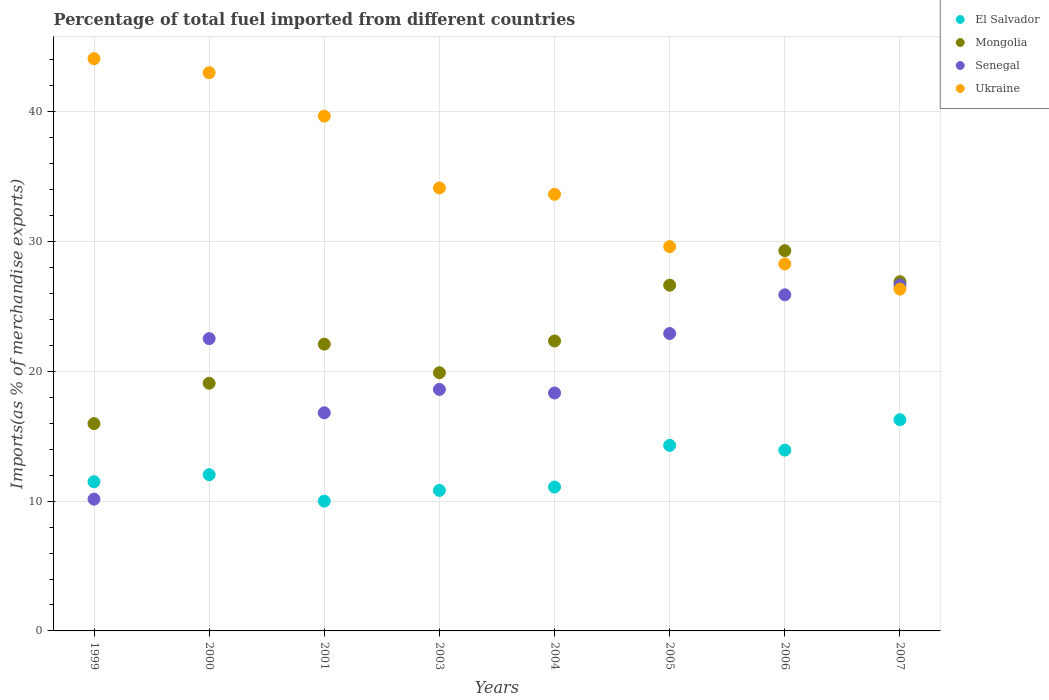Is the number of dotlines equal to the number of legend labels?
Keep it short and to the point. Yes. What is the percentage of imports to different countries in Ukraine in 2003?
Keep it short and to the point. 34.13. Across all years, what is the maximum percentage of imports to different countries in El Salvador?
Your answer should be compact. 16.27. Across all years, what is the minimum percentage of imports to different countries in Senegal?
Make the answer very short. 10.15. In which year was the percentage of imports to different countries in Mongolia maximum?
Your answer should be very brief. 2006. What is the total percentage of imports to different countries in Mongolia in the graph?
Make the answer very short. 182.22. What is the difference between the percentage of imports to different countries in Mongolia in 2000 and that in 2004?
Your answer should be compact. -3.26. What is the difference between the percentage of imports to different countries in El Salvador in 2003 and the percentage of imports to different countries in Senegal in 2005?
Make the answer very short. -12.09. What is the average percentage of imports to different countries in Mongolia per year?
Your response must be concise. 22.78. In the year 2000, what is the difference between the percentage of imports to different countries in El Salvador and percentage of imports to different countries in Mongolia?
Provide a succinct answer. -7.04. In how many years, is the percentage of imports to different countries in Ukraine greater than 18 %?
Offer a terse response. 8. What is the ratio of the percentage of imports to different countries in Ukraine in 1999 to that in 2004?
Give a very brief answer. 1.31. What is the difference between the highest and the second highest percentage of imports to different countries in Senegal?
Give a very brief answer. 0.76. What is the difference between the highest and the lowest percentage of imports to different countries in El Salvador?
Your answer should be compact. 6.27. Is the sum of the percentage of imports to different countries in Ukraine in 2000 and 2005 greater than the maximum percentage of imports to different countries in Mongolia across all years?
Provide a short and direct response. Yes. Is it the case that in every year, the sum of the percentage of imports to different countries in Ukraine and percentage of imports to different countries in Mongolia  is greater than the sum of percentage of imports to different countries in El Salvador and percentage of imports to different countries in Senegal?
Your answer should be compact. Yes. Is it the case that in every year, the sum of the percentage of imports to different countries in Mongolia and percentage of imports to different countries in Ukraine  is greater than the percentage of imports to different countries in Senegal?
Give a very brief answer. Yes. How many dotlines are there?
Offer a very short reply. 4. How many years are there in the graph?
Offer a terse response. 8. Are the values on the major ticks of Y-axis written in scientific E-notation?
Your answer should be compact. No. Does the graph contain any zero values?
Provide a short and direct response. No. Does the graph contain grids?
Offer a very short reply. Yes. Where does the legend appear in the graph?
Keep it short and to the point. Top right. How are the legend labels stacked?
Your response must be concise. Vertical. What is the title of the graph?
Give a very brief answer. Percentage of total fuel imported from different countries. Does "Swaziland" appear as one of the legend labels in the graph?
Give a very brief answer. No. What is the label or title of the Y-axis?
Give a very brief answer. Imports(as % of merchandise exports). What is the Imports(as % of merchandise exports) of El Salvador in 1999?
Provide a succinct answer. 11.49. What is the Imports(as % of merchandise exports) of Mongolia in 1999?
Provide a short and direct response. 15.97. What is the Imports(as % of merchandise exports) in Senegal in 1999?
Ensure brevity in your answer.  10.15. What is the Imports(as % of merchandise exports) of Ukraine in 1999?
Your answer should be very brief. 44.09. What is the Imports(as % of merchandise exports) of El Salvador in 2000?
Ensure brevity in your answer.  12.04. What is the Imports(as % of merchandise exports) in Mongolia in 2000?
Your response must be concise. 19.08. What is the Imports(as % of merchandise exports) in Senegal in 2000?
Make the answer very short. 22.52. What is the Imports(as % of merchandise exports) in Ukraine in 2000?
Offer a very short reply. 43.01. What is the Imports(as % of merchandise exports) in El Salvador in 2001?
Offer a very short reply. 10. What is the Imports(as % of merchandise exports) of Mongolia in 2001?
Provide a short and direct response. 22.09. What is the Imports(as % of merchandise exports) in Senegal in 2001?
Your answer should be compact. 16.8. What is the Imports(as % of merchandise exports) of Ukraine in 2001?
Offer a very short reply. 39.66. What is the Imports(as % of merchandise exports) of El Salvador in 2003?
Offer a very short reply. 10.83. What is the Imports(as % of merchandise exports) of Mongolia in 2003?
Your response must be concise. 19.89. What is the Imports(as % of merchandise exports) in Senegal in 2003?
Provide a succinct answer. 18.61. What is the Imports(as % of merchandise exports) of Ukraine in 2003?
Your answer should be compact. 34.13. What is the Imports(as % of merchandise exports) of El Salvador in 2004?
Your answer should be compact. 11.09. What is the Imports(as % of merchandise exports) of Mongolia in 2004?
Offer a terse response. 22.34. What is the Imports(as % of merchandise exports) in Senegal in 2004?
Keep it short and to the point. 18.33. What is the Imports(as % of merchandise exports) of Ukraine in 2004?
Your answer should be very brief. 33.64. What is the Imports(as % of merchandise exports) of El Salvador in 2005?
Keep it short and to the point. 14.29. What is the Imports(as % of merchandise exports) in Mongolia in 2005?
Give a very brief answer. 26.64. What is the Imports(as % of merchandise exports) in Senegal in 2005?
Provide a short and direct response. 22.91. What is the Imports(as % of merchandise exports) of Ukraine in 2005?
Your answer should be compact. 29.61. What is the Imports(as % of merchandise exports) in El Salvador in 2006?
Give a very brief answer. 13.93. What is the Imports(as % of merchandise exports) of Mongolia in 2006?
Offer a very short reply. 29.3. What is the Imports(as % of merchandise exports) of Senegal in 2006?
Offer a very short reply. 25.9. What is the Imports(as % of merchandise exports) in Ukraine in 2006?
Provide a succinct answer. 28.27. What is the Imports(as % of merchandise exports) in El Salvador in 2007?
Offer a very short reply. 16.27. What is the Imports(as % of merchandise exports) of Mongolia in 2007?
Provide a succinct answer. 26.9. What is the Imports(as % of merchandise exports) in Senegal in 2007?
Offer a very short reply. 26.66. What is the Imports(as % of merchandise exports) of Ukraine in 2007?
Keep it short and to the point. 26.33. Across all years, what is the maximum Imports(as % of merchandise exports) of El Salvador?
Your answer should be very brief. 16.27. Across all years, what is the maximum Imports(as % of merchandise exports) in Mongolia?
Provide a short and direct response. 29.3. Across all years, what is the maximum Imports(as % of merchandise exports) in Senegal?
Ensure brevity in your answer.  26.66. Across all years, what is the maximum Imports(as % of merchandise exports) of Ukraine?
Your answer should be compact. 44.09. Across all years, what is the minimum Imports(as % of merchandise exports) of El Salvador?
Give a very brief answer. 10. Across all years, what is the minimum Imports(as % of merchandise exports) of Mongolia?
Your answer should be very brief. 15.97. Across all years, what is the minimum Imports(as % of merchandise exports) of Senegal?
Your answer should be very brief. 10.15. Across all years, what is the minimum Imports(as % of merchandise exports) in Ukraine?
Provide a short and direct response. 26.33. What is the total Imports(as % of merchandise exports) of El Salvador in the graph?
Ensure brevity in your answer.  99.94. What is the total Imports(as % of merchandise exports) in Mongolia in the graph?
Offer a terse response. 182.22. What is the total Imports(as % of merchandise exports) in Senegal in the graph?
Your answer should be compact. 161.88. What is the total Imports(as % of merchandise exports) of Ukraine in the graph?
Ensure brevity in your answer.  278.74. What is the difference between the Imports(as % of merchandise exports) in El Salvador in 1999 and that in 2000?
Your answer should be compact. -0.55. What is the difference between the Imports(as % of merchandise exports) in Mongolia in 1999 and that in 2000?
Ensure brevity in your answer.  -3.11. What is the difference between the Imports(as % of merchandise exports) in Senegal in 1999 and that in 2000?
Provide a short and direct response. -12.37. What is the difference between the Imports(as % of merchandise exports) in Ukraine in 1999 and that in 2000?
Your response must be concise. 1.08. What is the difference between the Imports(as % of merchandise exports) in El Salvador in 1999 and that in 2001?
Offer a very short reply. 1.49. What is the difference between the Imports(as % of merchandise exports) in Mongolia in 1999 and that in 2001?
Give a very brief answer. -6.12. What is the difference between the Imports(as % of merchandise exports) of Senegal in 1999 and that in 2001?
Make the answer very short. -6.65. What is the difference between the Imports(as % of merchandise exports) of Ukraine in 1999 and that in 2001?
Provide a short and direct response. 4.43. What is the difference between the Imports(as % of merchandise exports) in El Salvador in 1999 and that in 2003?
Your answer should be compact. 0.67. What is the difference between the Imports(as % of merchandise exports) in Mongolia in 1999 and that in 2003?
Your response must be concise. -3.92. What is the difference between the Imports(as % of merchandise exports) of Senegal in 1999 and that in 2003?
Offer a terse response. -8.46. What is the difference between the Imports(as % of merchandise exports) in Ukraine in 1999 and that in 2003?
Keep it short and to the point. 9.96. What is the difference between the Imports(as % of merchandise exports) of El Salvador in 1999 and that in 2004?
Your answer should be compact. 0.41. What is the difference between the Imports(as % of merchandise exports) in Mongolia in 1999 and that in 2004?
Your answer should be very brief. -6.37. What is the difference between the Imports(as % of merchandise exports) in Senegal in 1999 and that in 2004?
Keep it short and to the point. -8.18. What is the difference between the Imports(as % of merchandise exports) of Ukraine in 1999 and that in 2004?
Make the answer very short. 10.45. What is the difference between the Imports(as % of merchandise exports) in El Salvador in 1999 and that in 2005?
Offer a very short reply. -2.8. What is the difference between the Imports(as % of merchandise exports) in Mongolia in 1999 and that in 2005?
Offer a terse response. -10.67. What is the difference between the Imports(as % of merchandise exports) in Senegal in 1999 and that in 2005?
Provide a short and direct response. -12.76. What is the difference between the Imports(as % of merchandise exports) in Ukraine in 1999 and that in 2005?
Ensure brevity in your answer.  14.48. What is the difference between the Imports(as % of merchandise exports) in El Salvador in 1999 and that in 2006?
Your response must be concise. -2.44. What is the difference between the Imports(as % of merchandise exports) in Mongolia in 1999 and that in 2006?
Provide a succinct answer. -13.32. What is the difference between the Imports(as % of merchandise exports) of Senegal in 1999 and that in 2006?
Make the answer very short. -15.75. What is the difference between the Imports(as % of merchandise exports) in Ukraine in 1999 and that in 2006?
Give a very brief answer. 15.82. What is the difference between the Imports(as % of merchandise exports) of El Salvador in 1999 and that in 2007?
Give a very brief answer. -4.78. What is the difference between the Imports(as % of merchandise exports) in Mongolia in 1999 and that in 2007?
Make the answer very short. -10.93. What is the difference between the Imports(as % of merchandise exports) in Senegal in 1999 and that in 2007?
Provide a succinct answer. -16.5. What is the difference between the Imports(as % of merchandise exports) of Ukraine in 1999 and that in 2007?
Provide a short and direct response. 17.75. What is the difference between the Imports(as % of merchandise exports) in El Salvador in 2000 and that in 2001?
Make the answer very short. 2.04. What is the difference between the Imports(as % of merchandise exports) in Mongolia in 2000 and that in 2001?
Ensure brevity in your answer.  -3.01. What is the difference between the Imports(as % of merchandise exports) in Senegal in 2000 and that in 2001?
Provide a succinct answer. 5.72. What is the difference between the Imports(as % of merchandise exports) in Ukraine in 2000 and that in 2001?
Make the answer very short. 3.35. What is the difference between the Imports(as % of merchandise exports) in El Salvador in 2000 and that in 2003?
Your response must be concise. 1.21. What is the difference between the Imports(as % of merchandise exports) in Mongolia in 2000 and that in 2003?
Offer a very short reply. -0.81. What is the difference between the Imports(as % of merchandise exports) in Senegal in 2000 and that in 2003?
Make the answer very short. 3.91. What is the difference between the Imports(as % of merchandise exports) in Ukraine in 2000 and that in 2003?
Give a very brief answer. 8.88. What is the difference between the Imports(as % of merchandise exports) of El Salvador in 2000 and that in 2004?
Ensure brevity in your answer.  0.95. What is the difference between the Imports(as % of merchandise exports) of Mongolia in 2000 and that in 2004?
Provide a short and direct response. -3.26. What is the difference between the Imports(as % of merchandise exports) of Senegal in 2000 and that in 2004?
Provide a short and direct response. 4.19. What is the difference between the Imports(as % of merchandise exports) in Ukraine in 2000 and that in 2004?
Make the answer very short. 9.37. What is the difference between the Imports(as % of merchandise exports) in El Salvador in 2000 and that in 2005?
Make the answer very short. -2.26. What is the difference between the Imports(as % of merchandise exports) of Mongolia in 2000 and that in 2005?
Your answer should be very brief. -7.56. What is the difference between the Imports(as % of merchandise exports) in Senegal in 2000 and that in 2005?
Offer a terse response. -0.39. What is the difference between the Imports(as % of merchandise exports) in Ukraine in 2000 and that in 2005?
Ensure brevity in your answer.  13.4. What is the difference between the Imports(as % of merchandise exports) in El Salvador in 2000 and that in 2006?
Your response must be concise. -1.89. What is the difference between the Imports(as % of merchandise exports) in Mongolia in 2000 and that in 2006?
Your response must be concise. -10.21. What is the difference between the Imports(as % of merchandise exports) of Senegal in 2000 and that in 2006?
Your answer should be very brief. -3.38. What is the difference between the Imports(as % of merchandise exports) in Ukraine in 2000 and that in 2006?
Give a very brief answer. 14.74. What is the difference between the Imports(as % of merchandise exports) of El Salvador in 2000 and that in 2007?
Keep it short and to the point. -4.23. What is the difference between the Imports(as % of merchandise exports) of Mongolia in 2000 and that in 2007?
Offer a terse response. -7.82. What is the difference between the Imports(as % of merchandise exports) of Senegal in 2000 and that in 2007?
Ensure brevity in your answer.  -4.14. What is the difference between the Imports(as % of merchandise exports) of Ukraine in 2000 and that in 2007?
Provide a succinct answer. 16.68. What is the difference between the Imports(as % of merchandise exports) in El Salvador in 2001 and that in 2003?
Your answer should be very brief. -0.83. What is the difference between the Imports(as % of merchandise exports) of Mongolia in 2001 and that in 2003?
Give a very brief answer. 2.2. What is the difference between the Imports(as % of merchandise exports) in Senegal in 2001 and that in 2003?
Provide a short and direct response. -1.8. What is the difference between the Imports(as % of merchandise exports) in Ukraine in 2001 and that in 2003?
Offer a terse response. 5.53. What is the difference between the Imports(as % of merchandise exports) in El Salvador in 2001 and that in 2004?
Make the answer very short. -1.09. What is the difference between the Imports(as % of merchandise exports) in Mongolia in 2001 and that in 2004?
Keep it short and to the point. -0.24. What is the difference between the Imports(as % of merchandise exports) of Senegal in 2001 and that in 2004?
Your response must be concise. -1.53. What is the difference between the Imports(as % of merchandise exports) in Ukraine in 2001 and that in 2004?
Provide a short and direct response. 6.02. What is the difference between the Imports(as % of merchandise exports) in El Salvador in 2001 and that in 2005?
Ensure brevity in your answer.  -4.29. What is the difference between the Imports(as % of merchandise exports) in Mongolia in 2001 and that in 2005?
Your answer should be very brief. -4.54. What is the difference between the Imports(as % of merchandise exports) of Senegal in 2001 and that in 2005?
Your response must be concise. -6.11. What is the difference between the Imports(as % of merchandise exports) of Ukraine in 2001 and that in 2005?
Your answer should be compact. 10.05. What is the difference between the Imports(as % of merchandise exports) in El Salvador in 2001 and that in 2006?
Offer a very short reply. -3.93. What is the difference between the Imports(as % of merchandise exports) in Mongolia in 2001 and that in 2006?
Provide a succinct answer. -7.2. What is the difference between the Imports(as % of merchandise exports) of Senegal in 2001 and that in 2006?
Keep it short and to the point. -9.09. What is the difference between the Imports(as % of merchandise exports) in Ukraine in 2001 and that in 2006?
Your answer should be very brief. 11.39. What is the difference between the Imports(as % of merchandise exports) of El Salvador in 2001 and that in 2007?
Ensure brevity in your answer.  -6.27. What is the difference between the Imports(as % of merchandise exports) in Mongolia in 2001 and that in 2007?
Make the answer very short. -4.81. What is the difference between the Imports(as % of merchandise exports) in Senegal in 2001 and that in 2007?
Your answer should be very brief. -9.85. What is the difference between the Imports(as % of merchandise exports) of Ukraine in 2001 and that in 2007?
Your response must be concise. 13.33. What is the difference between the Imports(as % of merchandise exports) in El Salvador in 2003 and that in 2004?
Offer a terse response. -0.26. What is the difference between the Imports(as % of merchandise exports) in Mongolia in 2003 and that in 2004?
Keep it short and to the point. -2.45. What is the difference between the Imports(as % of merchandise exports) in Senegal in 2003 and that in 2004?
Ensure brevity in your answer.  0.28. What is the difference between the Imports(as % of merchandise exports) of Ukraine in 2003 and that in 2004?
Your answer should be very brief. 0.49. What is the difference between the Imports(as % of merchandise exports) of El Salvador in 2003 and that in 2005?
Your response must be concise. -3.47. What is the difference between the Imports(as % of merchandise exports) in Mongolia in 2003 and that in 2005?
Offer a terse response. -6.75. What is the difference between the Imports(as % of merchandise exports) in Senegal in 2003 and that in 2005?
Your response must be concise. -4.3. What is the difference between the Imports(as % of merchandise exports) of Ukraine in 2003 and that in 2005?
Make the answer very short. 4.52. What is the difference between the Imports(as % of merchandise exports) in El Salvador in 2003 and that in 2006?
Offer a terse response. -3.1. What is the difference between the Imports(as % of merchandise exports) of Mongolia in 2003 and that in 2006?
Your answer should be compact. -9.41. What is the difference between the Imports(as % of merchandise exports) of Senegal in 2003 and that in 2006?
Provide a short and direct response. -7.29. What is the difference between the Imports(as % of merchandise exports) in Ukraine in 2003 and that in 2006?
Your response must be concise. 5.86. What is the difference between the Imports(as % of merchandise exports) in El Salvador in 2003 and that in 2007?
Your answer should be compact. -5.45. What is the difference between the Imports(as % of merchandise exports) of Mongolia in 2003 and that in 2007?
Give a very brief answer. -7.01. What is the difference between the Imports(as % of merchandise exports) of Senegal in 2003 and that in 2007?
Your answer should be compact. -8.05. What is the difference between the Imports(as % of merchandise exports) of Ukraine in 2003 and that in 2007?
Provide a short and direct response. 7.8. What is the difference between the Imports(as % of merchandise exports) in El Salvador in 2004 and that in 2005?
Provide a short and direct response. -3.21. What is the difference between the Imports(as % of merchandise exports) of Mongolia in 2004 and that in 2005?
Ensure brevity in your answer.  -4.3. What is the difference between the Imports(as % of merchandise exports) in Senegal in 2004 and that in 2005?
Your answer should be compact. -4.58. What is the difference between the Imports(as % of merchandise exports) in Ukraine in 2004 and that in 2005?
Offer a terse response. 4.03. What is the difference between the Imports(as % of merchandise exports) in El Salvador in 2004 and that in 2006?
Your answer should be very brief. -2.84. What is the difference between the Imports(as % of merchandise exports) in Mongolia in 2004 and that in 2006?
Ensure brevity in your answer.  -6.96. What is the difference between the Imports(as % of merchandise exports) in Senegal in 2004 and that in 2006?
Offer a terse response. -7.57. What is the difference between the Imports(as % of merchandise exports) in Ukraine in 2004 and that in 2006?
Offer a terse response. 5.36. What is the difference between the Imports(as % of merchandise exports) in El Salvador in 2004 and that in 2007?
Your response must be concise. -5.19. What is the difference between the Imports(as % of merchandise exports) in Mongolia in 2004 and that in 2007?
Offer a very short reply. -4.57. What is the difference between the Imports(as % of merchandise exports) of Senegal in 2004 and that in 2007?
Ensure brevity in your answer.  -8.32. What is the difference between the Imports(as % of merchandise exports) in Ukraine in 2004 and that in 2007?
Keep it short and to the point. 7.3. What is the difference between the Imports(as % of merchandise exports) of El Salvador in 2005 and that in 2006?
Keep it short and to the point. 0.36. What is the difference between the Imports(as % of merchandise exports) of Mongolia in 2005 and that in 2006?
Keep it short and to the point. -2.66. What is the difference between the Imports(as % of merchandise exports) of Senegal in 2005 and that in 2006?
Provide a succinct answer. -2.99. What is the difference between the Imports(as % of merchandise exports) in Ukraine in 2005 and that in 2006?
Ensure brevity in your answer.  1.34. What is the difference between the Imports(as % of merchandise exports) of El Salvador in 2005 and that in 2007?
Make the answer very short. -1.98. What is the difference between the Imports(as % of merchandise exports) of Mongolia in 2005 and that in 2007?
Your answer should be compact. -0.27. What is the difference between the Imports(as % of merchandise exports) in Senegal in 2005 and that in 2007?
Make the answer very short. -3.74. What is the difference between the Imports(as % of merchandise exports) in Ukraine in 2005 and that in 2007?
Offer a very short reply. 3.27. What is the difference between the Imports(as % of merchandise exports) of El Salvador in 2006 and that in 2007?
Ensure brevity in your answer.  -2.34. What is the difference between the Imports(as % of merchandise exports) of Mongolia in 2006 and that in 2007?
Your answer should be very brief. 2.39. What is the difference between the Imports(as % of merchandise exports) of Senegal in 2006 and that in 2007?
Provide a short and direct response. -0.76. What is the difference between the Imports(as % of merchandise exports) of Ukraine in 2006 and that in 2007?
Give a very brief answer. 1.94. What is the difference between the Imports(as % of merchandise exports) of El Salvador in 1999 and the Imports(as % of merchandise exports) of Mongolia in 2000?
Keep it short and to the point. -7.59. What is the difference between the Imports(as % of merchandise exports) of El Salvador in 1999 and the Imports(as % of merchandise exports) of Senegal in 2000?
Keep it short and to the point. -11.03. What is the difference between the Imports(as % of merchandise exports) in El Salvador in 1999 and the Imports(as % of merchandise exports) in Ukraine in 2000?
Your answer should be compact. -31.52. What is the difference between the Imports(as % of merchandise exports) of Mongolia in 1999 and the Imports(as % of merchandise exports) of Senegal in 2000?
Give a very brief answer. -6.55. What is the difference between the Imports(as % of merchandise exports) of Mongolia in 1999 and the Imports(as % of merchandise exports) of Ukraine in 2000?
Keep it short and to the point. -27.04. What is the difference between the Imports(as % of merchandise exports) of Senegal in 1999 and the Imports(as % of merchandise exports) of Ukraine in 2000?
Offer a terse response. -32.86. What is the difference between the Imports(as % of merchandise exports) in El Salvador in 1999 and the Imports(as % of merchandise exports) in Mongolia in 2001?
Provide a short and direct response. -10.6. What is the difference between the Imports(as % of merchandise exports) of El Salvador in 1999 and the Imports(as % of merchandise exports) of Senegal in 2001?
Your response must be concise. -5.31. What is the difference between the Imports(as % of merchandise exports) of El Salvador in 1999 and the Imports(as % of merchandise exports) of Ukraine in 2001?
Your response must be concise. -28.17. What is the difference between the Imports(as % of merchandise exports) in Mongolia in 1999 and the Imports(as % of merchandise exports) in Senegal in 2001?
Make the answer very short. -0.83. What is the difference between the Imports(as % of merchandise exports) in Mongolia in 1999 and the Imports(as % of merchandise exports) in Ukraine in 2001?
Offer a terse response. -23.69. What is the difference between the Imports(as % of merchandise exports) in Senegal in 1999 and the Imports(as % of merchandise exports) in Ukraine in 2001?
Your response must be concise. -29.51. What is the difference between the Imports(as % of merchandise exports) of El Salvador in 1999 and the Imports(as % of merchandise exports) of Mongolia in 2003?
Keep it short and to the point. -8.4. What is the difference between the Imports(as % of merchandise exports) in El Salvador in 1999 and the Imports(as % of merchandise exports) in Senegal in 2003?
Make the answer very short. -7.12. What is the difference between the Imports(as % of merchandise exports) in El Salvador in 1999 and the Imports(as % of merchandise exports) in Ukraine in 2003?
Make the answer very short. -22.64. What is the difference between the Imports(as % of merchandise exports) in Mongolia in 1999 and the Imports(as % of merchandise exports) in Senegal in 2003?
Provide a short and direct response. -2.63. What is the difference between the Imports(as % of merchandise exports) of Mongolia in 1999 and the Imports(as % of merchandise exports) of Ukraine in 2003?
Your answer should be compact. -18.16. What is the difference between the Imports(as % of merchandise exports) in Senegal in 1999 and the Imports(as % of merchandise exports) in Ukraine in 2003?
Provide a succinct answer. -23.98. What is the difference between the Imports(as % of merchandise exports) of El Salvador in 1999 and the Imports(as % of merchandise exports) of Mongolia in 2004?
Your answer should be compact. -10.85. What is the difference between the Imports(as % of merchandise exports) of El Salvador in 1999 and the Imports(as % of merchandise exports) of Senegal in 2004?
Provide a short and direct response. -6.84. What is the difference between the Imports(as % of merchandise exports) in El Salvador in 1999 and the Imports(as % of merchandise exports) in Ukraine in 2004?
Give a very brief answer. -22.14. What is the difference between the Imports(as % of merchandise exports) in Mongolia in 1999 and the Imports(as % of merchandise exports) in Senegal in 2004?
Offer a very short reply. -2.36. What is the difference between the Imports(as % of merchandise exports) of Mongolia in 1999 and the Imports(as % of merchandise exports) of Ukraine in 2004?
Give a very brief answer. -17.66. What is the difference between the Imports(as % of merchandise exports) of Senegal in 1999 and the Imports(as % of merchandise exports) of Ukraine in 2004?
Your answer should be compact. -23.48. What is the difference between the Imports(as % of merchandise exports) in El Salvador in 1999 and the Imports(as % of merchandise exports) in Mongolia in 2005?
Your answer should be compact. -15.15. What is the difference between the Imports(as % of merchandise exports) of El Salvador in 1999 and the Imports(as % of merchandise exports) of Senegal in 2005?
Provide a short and direct response. -11.42. What is the difference between the Imports(as % of merchandise exports) in El Salvador in 1999 and the Imports(as % of merchandise exports) in Ukraine in 2005?
Your answer should be very brief. -18.12. What is the difference between the Imports(as % of merchandise exports) of Mongolia in 1999 and the Imports(as % of merchandise exports) of Senegal in 2005?
Offer a very short reply. -6.94. What is the difference between the Imports(as % of merchandise exports) in Mongolia in 1999 and the Imports(as % of merchandise exports) in Ukraine in 2005?
Give a very brief answer. -13.63. What is the difference between the Imports(as % of merchandise exports) of Senegal in 1999 and the Imports(as % of merchandise exports) of Ukraine in 2005?
Keep it short and to the point. -19.46. What is the difference between the Imports(as % of merchandise exports) in El Salvador in 1999 and the Imports(as % of merchandise exports) in Mongolia in 2006?
Keep it short and to the point. -17.8. What is the difference between the Imports(as % of merchandise exports) of El Salvador in 1999 and the Imports(as % of merchandise exports) of Senegal in 2006?
Your answer should be very brief. -14.41. What is the difference between the Imports(as % of merchandise exports) of El Salvador in 1999 and the Imports(as % of merchandise exports) of Ukraine in 2006?
Ensure brevity in your answer.  -16.78. What is the difference between the Imports(as % of merchandise exports) in Mongolia in 1999 and the Imports(as % of merchandise exports) in Senegal in 2006?
Your answer should be very brief. -9.92. What is the difference between the Imports(as % of merchandise exports) of Mongolia in 1999 and the Imports(as % of merchandise exports) of Ukraine in 2006?
Provide a short and direct response. -12.3. What is the difference between the Imports(as % of merchandise exports) in Senegal in 1999 and the Imports(as % of merchandise exports) in Ukraine in 2006?
Offer a very short reply. -18.12. What is the difference between the Imports(as % of merchandise exports) in El Salvador in 1999 and the Imports(as % of merchandise exports) in Mongolia in 2007?
Provide a succinct answer. -15.41. What is the difference between the Imports(as % of merchandise exports) of El Salvador in 1999 and the Imports(as % of merchandise exports) of Senegal in 2007?
Offer a terse response. -15.16. What is the difference between the Imports(as % of merchandise exports) of El Salvador in 1999 and the Imports(as % of merchandise exports) of Ukraine in 2007?
Your answer should be compact. -14.84. What is the difference between the Imports(as % of merchandise exports) in Mongolia in 1999 and the Imports(as % of merchandise exports) in Senegal in 2007?
Make the answer very short. -10.68. What is the difference between the Imports(as % of merchandise exports) in Mongolia in 1999 and the Imports(as % of merchandise exports) in Ukraine in 2007?
Provide a short and direct response. -10.36. What is the difference between the Imports(as % of merchandise exports) in Senegal in 1999 and the Imports(as % of merchandise exports) in Ukraine in 2007?
Make the answer very short. -16.18. What is the difference between the Imports(as % of merchandise exports) of El Salvador in 2000 and the Imports(as % of merchandise exports) of Mongolia in 2001?
Your answer should be very brief. -10.06. What is the difference between the Imports(as % of merchandise exports) in El Salvador in 2000 and the Imports(as % of merchandise exports) in Senegal in 2001?
Your response must be concise. -4.77. What is the difference between the Imports(as % of merchandise exports) of El Salvador in 2000 and the Imports(as % of merchandise exports) of Ukraine in 2001?
Provide a short and direct response. -27.62. What is the difference between the Imports(as % of merchandise exports) of Mongolia in 2000 and the Imports(as % of merchandise exports) of Senegal in 2001?
Offer a terse response. 2.28. What is the difference between the Imports(as % of merchandise exports) in Mongolia in 2000 and the Imports(as % of merchandise exports) in Ukraine in 2001?
Your answer should be compact. -20.58. What is the difference between the Imports(as % of merchandise exports) in Senegal in 2000 and the Imports(as % of merchandise exports) in Ukraine in 2001?
Your answer should be compact. -17.14. What is the difference between the Imports(as % of merchandise exports) in El Salvador in 2000 and the Imports(as % of merchandise exports) in Mongolia in 2003?
Offer a terse response. -7.85. What is the difference between the Imports(as % of merchandise exports) of El Salvador in 2000 and the Imports(as % of merchandise exports) of Senegal in 2003?
Your response must be concise. -6.57. What is the difference between the Imports(as % of merchandise exports) in El Salvador in 2000 and the Imports(as % of merchandise exports) in Ukraine in 2003?
Provide a short and direct response. -22.09. What is the difference between the Imports(as % of merchandise exports) in Mongolia in 2000 and the Imports(as % of merchandise exports) in Senegal in 2003?
Your response must be concise. 0.47. What is the difference between the Imports(as % of merchandise exports) of Mongolia in 2000 and the Imports(as % of merchandise exports) of Ukraine in 2003?
Keep it short and to the point. -15.05. What is the difference between the Imports(as % of merchandise exports) in Senegal in 2000 and the Imports(as % of merchandise exports) in Ukraine in 2003?
Your answer should be very brief. -11.61. What is the difference between the Imports(as % of merchandise exports) of El Salvador in 2000 and the Imports(as % of merchandise exports) of Mongolia in 2004?
Your answer should be very brief. -10.3. What is the difference between the Imports(as % of merchandise exports) of El Salvador in 2000 and the Imports(as % of merchandise exports) of Senegal in 2004?
Your answer should be very brief. -6.29. What is the difference between the Imports(as % of merchandise exports) of El Salvador in 2000 and the Imports(as % of merchandise exports) of Ukraine in 2004?
Provide a succinct answer. -21.6. What is the difference between the Imports(as % of merchandise exports) of Mongolia in 2000 and the Imports(as % of merchandise exports) of Senegal in 2004?
Give a very brief answer. 0.75. What is the difference between the Imports(as % of merchandise exports) of Mongolia in 2000 and the Imports(as % of merchandise exports) of Ukraine in 2004?
Keep it short and to the point. -14.55. What is the difference between the Imports(as % of merchandise exports) of Senegal in 2000 and the Imports(as % of merchandise exports) of Ukraine in 2004?
Your answer should be compact. -11.12. What is the difference between the Imports(as % of merchandise exports) in El Salvador in 2000 and the Imports(as % of merchandise exports) in Mongolia in 2005?
Make the answer very short. -14.6. What is the difference between the Imports(as % of merchandise exports) of El Salvador in 2000 and the Imports(as % of merchandise exports) of Senegal in 2005?
Provide a short and direct response. -10.87. What is the difference between the Imports(as % of merchandise exports) of El Salvador in 2000 and the Imports(as % of merchandise exports) of Ukraine in 2005?
Provide a succinct answer. -17.57. What is the difference between the Imports(as % of merchandise exports) in Mongolia in 2000 and the Imports(as % of merchandise exports) in Senegal in 2005?
Keep it short and to the point. -3.83. What is the difference between the Imports(as % of merchandise exports) of Mongolia in 2000 and the Imports(as % of merchandise exports) of Ukraine in 2005?
Make the answer very short. -10.53. What is the difference between the Imports(as % of merchandise exports) of Senegal in 2000 and the Imports(as % of merchandise exports) of Ukraine in 2005?
Offer a very short reply. -7.09. What is the difference between the Imports(as % of merchandise exports) in El Salvador in 2000 and the Imports(as % of merchandise exports) in Mongolia in 2006?
Your answer should be very brief. -17.26. What is the difference between the Imports(as % of merchandise exports) in El Salvador in 2000 and the Imports(as % of merchandise exports) in Senegal in 2006?
Keep it short and to the point. -13.86. What is the difference between the Imports(as % of merchandise exports) of El Salvador in 2000 and the Imports(as % of merchandise exports) of Ukraine in 2006?
Give a very brief answer. -16.23. What is the difference between the Imports(as % of merchandise exports) in Mongolia in 2000 and the Imports(as % of merchandise exports) in Senegal in 2006?
Offer a terse response. -6.82. What is the difference between the Imports(as % of merchandise exports) in Mongolia in 2000 and the Imports(as % of merchandise exports) in Ukraine in 2006?
Ensure brevity in your answer.  -9.19. What is the difference between the Imports(as % of merchandise exports) of Senegal in 2000 and the Imports(as % of merchandise exports) of Ukraine in 2006?
Your answer should be compact. -5.75. What is the difference between the Imports(as % of merchandise exports) of El Salvador in 2000 and the Imports(as % of merchandise exports) of Mongolia in 2007?
Your answer should be compact. -14.87. What is the difference between the Imports(as % of merchandise exports) in El Salvador in 2000 and the Imports(as % of merchandise exports) in Senegal in 2007?
Give a very brief answer. -14.62. What is the difference between the Imports(as % of merchandise exports) of El Salvador in 2000 and the Imports(as % of merchandise exports) of Ukraine in 2007?
Your answer should be very brief. -14.29. What is the difference between the Imports(as % of merchandise exports) in Mongolia in 2000 and the Imports(as % of merchandise exports) in Senegal in 2007?
Offer a terse response. -7.57. What is the difference between the Imports(as % of merchandise exports) in Mongolia in 2000 and the Imports(as % of merchandise exports) in Ukraine in 2007?
Your answer should be compact. -7.25. What is the difference between the Imports(as % of merchandise exports) in Senegal in 2000 and the Imports(as % of merchandise exports) in Ukraine in 2007?
Your answer should be compact. -3.81. What is the difference between the Imports(as % of merchandise exports) in El Salvador in 2001 and the Imports(as % of merchandise exports) in Mongolia in 2003?
Ensure brevity in your answer.  -9.89. What is the difference between the Imports(as % of merchandise exports) in El Salvador in 2001 and the Imports(as % of merchandise exports) in Senegal in 2003?
Give a very brief answer. -8.61. What is the difference between the Imports(as % of merchandise exports) in El Salvador in 2001 and the Imports(as % of merchandise exports) in Ukraine in 2003?
Ensure brevity in your answer.  -24.13. What is the difference between the Imports(as % of merchandise exports) of Mongolia in 2001 and the Imports(as % of merchandise exports) of Senegal in 2003?
Provide a succinct answer. 3.49. What is the difference between the Imports(as % of merchandise exports) of Mongolia in 2001 and the Imports(as % of merchandise exports) of Ukraine in 2003?
Your answer should be compact. -12.04. What is the difference between the Imports(as % of merchandise exports) of Senegal in 2001 and the Imports(as % of merchandise exports) of Ukraine in 2003?
Provide a short and direct response. -17.32. What is the difference between the Imports(as % of merchandise exports) in El Salvador in 2001 and the Imports(as % of merchandise exports) in Mongolia in 2004?
Provide a short and direct response. -12.34. What is the difference between the Imports(as % of merchandise exports) of El Salvador in 2001 and the Imports(as % of merchandise exports) of Senegal in 2004?
Offer a terse response. -8.33. What is the difference between the Imports(as % of merchandise exports) of El Salvador in 2001 and the Imports(as % of merchandise exports) of Ukraine in 2004?
Your response must be concise. -23.64. What is the difference between the Imports(as % of merchandise exports) in Mongolia in 2001 and the Imports(as % of merchandise exports) in Senegal in 2004?
Ensure brevity in your answer.  3.76. What is the difference between the Imports(as % of merchandise exports) in Mongolia in 2001 and the Imports(as % of merchandise exports) in Ukraine in 2004?
Offer a terse response. -11.54. What is the difference between the Imports(as % of merchandise exports) in Senegal in 2001 and the Imports(as % of merchandise exports) in Ukraine in 2004?
Ensure brevity in your answer.  -16.83. What is the difference between the Imports(as % of merchandise exports) of El Salvador in 2001 and the Imports(as % of merchandise exports) of Mongolia in 2005?
Your response must be concise. -16.64. What is the difference between the Imports(as % of merchandise exports) in El Salvador in 2001 and the Imports(as % of merchandise exports) in Senegal in 2005?
Your answer should be compact. -12.91. What is the difference between the Imports(as % of merchandise exports) in El Salvador in 2001 and the Imports(as % of merchandise exports) in Ukraine in 2005?
Your response must be concise. -19.61. What is the difference between the Imports(as % of merchandise exports) in Mongolia in 2001 and the Imports(as % of merchandise exports) in Senegal in 2005?
Your response must be concise. -0.82. What is the difference between the Imports(as % of merchandise exports) in Mongolia in 2001 and the Imports(as % of merchandise exports) in Ukraine in 2005?
Offer a very short reply. -7.51. What is the difference between the Imports(as % of merchandise exports) of Senegal in 2001 and the Imports(as % of merchandise exports) of Ukraine in 2005?
Ensure brevity in your answer.  -12.8. What is the difference between the Imports(as % of merchandise exports) in El Salvador in 2001 and the Imports(as % of merchandise exports) in Mongolia in 2006?
Keep it short and to the point. -19.3. What is the difference between the Imports(as % of merchandise exports) in El Salvador in 2001 and the Imports(as % of merchandise exports) in Senegal in 2006?
Your answer should be compact. -15.9. What is the difference between the Imports(as % of merchandise exports) in El Salvador in 2001 and the Imports(as % of merchandise exports) in Ukraine in 2006?
Offer a very short reply. -18.27. What is the difference between the Imports(as % of merchandise exports) in Mongolia in 2001 and the Imports(as % of merchandise exports) in Senegal in 2006?
Your answer should be very brief. -3.8. What is the difference between the Imports(as % of merchandise exports) of Mongolia in 2001 and the Imports(as % of merchandise exports) of Ukraine in 2006?
Offer a terse response. -6.18. What is the difference between the Imports(as % of merchandise exports) of Senegal in 2001 and the Imports(as % of merchandise exports) of Ukraine in 2006?
Your response must be concise. -11.47. What is the difference between the Imports(as % of merchandise exports) in El Salvador in 2001 and the Imports(as % of merchandise exports) in Mongolia in 2007?
Ensure brevity in your answer.  -16.9. What is the difference between the Imports(as % of merchandise exports) in El Salvador in 2001 and the Imports(as % of merchandise exports) in Senegal in 2007?
Make the answer very short. -16.66. What is the difference between the Imports(as % of merchandise exports) of El Salvador in 2001 and the Imports(as % of merchandise exports) of Ukraine in 2007?
Your answer should be compact. -16.33. What is the difference between the Imports(as % of merchandise exports) of Mongolia in 2001 and the Imports(as % of merchandise exports) of Senegal in 2007?
Ensure brevity in your answer.  -4.56. What is the difference between the Imports(as % of merchandise exports) of Mongolia in 2001 and the Imports(as % of merchandise exports) of Ukraine in 2007?
Ensure brevity in your answer.  -4.24. What is the difference between the Imports(as % of merchandise exports) in Senegal in 2001 and the Imports(as % of merchandise exports) in Ukraine in 2007?
Make the answer very short. -9.53. What is the difference between the Imports(as % of merchandise exports) in El Salvador in 2003 and the Imports(as % of merchandise exports) in Mongolia in 2004?
Provide a short and direct response. -11.51. What is the difference between the Imports(as % of merchandise exports) in El Salvador in 2003 and the Imports(as % of merchandise exports) in Senegal in 2004?
Provide a short and direct response. -7.5. What is the difference between the Imports(as % of merchandise exports) of El Salvador in 2003 and the Imports(as % of merchandise exports) of Ukraine in 2004?
Your answer should be very brief. -22.81. What is the difference between the Imports(as % of merchandise exports) in Mongolia in 2003 and the Imports(as % of merchandise exports) in Senegal in 2004?
Your response must be concise. 1.56. What is the difference between the Imports(as % of merchandise exports) in Mongolia in 2003 and the Imports(as % of merchandise exports) in Ukraine in 2004?
Offer a terse response. -13.74. What is the difference between the Imports(as % of merchandise exports) in Senegal in 2003 and the Imports(as % of merchandise exports) in Ukraine in 2004?
Make the answer very short. -15.03. What is the difference between the Imports(as % of merchandise exports) of El Salvador in 2003 and the Imports(as % of merchandise exports) of Mongolia in 2005?
Ensure brevity in your answer.  -15.81. What is the difference between the Imports(as % of merchandise exports) of El Salvador in 2003 and the Imports(as % of merchandise exports) of Senegal in 2005?
Provide a short and direct response. -12.09. What is the difference between the Imports(as % of merchandise exports) of El Salvador in 2003 and the Imports(as % of merchandise exports) of Ukraine in 2005?
Give a very brief answer. -18.78. What is the difference between the Imports(as % of merchandise exports) in Mongolia in 2003 and the Imports(as % of merchandise exports) in Senegal in 2005?
Your answer should be compact. -3.02. What is the difference between the Imports(as % of merchandise exports) in Mongolia in 2003 and the Imports(as % of merchandise exports) in Ukraine in 2005?
Your response must be concise. -9.72. What is the difference between the Imports(as % of merchandise exports) in Senegal in 2003 and the Imports(as % of merchandise exports) in Ukraine in 2005?
Your response must be concise. -11. What is the difference between the Imports(as % of merchandise exports) of El Salvador in 2003 and the Imports(as % of merchandise exports) of Mongolia in 2006?
Provide a succinct answer. -18.47. What is the difference between the Imports(as % of merchandise exports) in El Salvador in 2003 and the Imports(as % of merchandise exports) in Senegal in 2006?
Give a very brief answer. -15.07. What is the difference between the Imports(as % of merchandise exports) of El Salvador in 2003 and the Imports(as % of merchandise exports) of Ukraine in 2006?
Provide a succinct answer. -17.44. What is the difference between the Imports(as % of merchandise exports) in Mongolia in 2003 and the Imports(as % of merchandise exports) in Senegal in 2006?
Provide a short and direct response. -6.01. What is the difference between the Imports(as % of merchandise exports) of Mongolia in 2003 and the Imports(as % of merchandise exports) of Ukraine in 2006?
Offer a terse response. -8.38. What is the difference between the Imports(as % of merchandise exports) of Senegal in 2003 and the Imports(as % of merchandise exports) of Ukraine in 2006?
Your response must be concise. -9.66. What is the difference between the Imports(as % of merchandise exports) in El Salvador in 2003 and the Imports(as % of merchandise exports) in Mongolia in 2007?
Offer a very short reply. -16.08. What is the difference between the Imports(as % of merchandise exports) of El Salvador in 2003 and the Imports(as % of merchandise exports) of Senegal in 2007?
Keep it short and to the point. -15.83. What is the difference between the Imports(as % of merchandise exports) of El Salvador in 2003 and the Imports(as % of merchandise exports) of Ukraine in 2007?
Offer a terse response. -15.51. What is the difference between the Imports(as % of merchandise exports) in Mongolia in 2003 and the Imports(as % of merchandise exports) in Senegal in 2007?
Keep it short and to the point. -6.76. What is the difference between the Imports(as % of merchandise exports) in Mongolia in 2003 and the Imports(as % of merchandise exports) in Ukraine in 2007?
Offer a terse response. -6.44. What is the difference between the Imports(as % of merchandise exports) in Senegal in 2003 and the Imports(as % of merchandise exports) in Ukraine in 2007?
Your response must be concise. -7.73. What is the difference between the Imports(as % of merchandise exports) in El Salvador in 2004 and the Imports(as % of merchandise exports) in Mongolia in 2005?
Your answer should be very brief. -15.55. What is the difference between the Imports(as % of merchandise exports) in El Salvador in 2004 and the Imports(as % of merchandise exports) in Senegal in 2005?
Ensure brevity in your answer.  -11.83. What is the difference between the Imports(as % of merchandise exports) of El Salvador in 2004 and the Imports(as % of merchandise exports) of Ukraine in 2005?
Provide a short and direct response. -18.52. What is the difference between the Imports(as % of merchandise exports) in Mongolia in 2004 and the Imports(as % of merchandise exports) in Senegal in 2005?
Your response must be concise. -0.57. What is the difference between the Imports(as % of merchandise exports) of Mongolia in 2004 and the Imports(as % of merchandise exports) of Ukraine in 2005?
Provide a short and direct response. -7.27. What is the difference between the Imports(as % of merchandise exports) in Senegal in 2004 and the Imports(as % of merchandise exports) in Ukraine in 2005?
Provide a short and direct response. -11.28. What is the difference between the Imports(as % of merchandise exports) of El Salvador in 2004 and the Imports(as % of merchandise exports) of Mongolia in 2006?
Offer a very short reply. -18.21. What is the difference between the Imports(as % of merchandise exports) in El Salvador in 2004 and the Imports(as % of merchandise exports) in Senegal in 2006?
Your answer should be very brief. -14.81. What is the difference between the Imports(as % of merchandise exports) of El Salvador in 2004 and the Imports(as % of merchandise exports) of Ukraine in 2006?
Your response must be concise. -17.19. What is the difference between the Imports(as % of merchandise exports) in Mongolia in 2004 and the Imports(as % of merchandise exports) in Senegal in 2006?
Keep it short and to the point. -3.56. What is the difference between the Imports(as % of merchandise exports) of Mongolia in 2004 and the Imports(as % of merchandise exports) of Ukraine in 2006?
Make the answer very short. -5.93. What is the difference between the Imports(as % of merchandise exports) of Senegal in 2004 and the Imports(as % of merchandise exports) of Ukraine in 2006?
Make the answer very short. -9.94. What is the difference between the Imports(as % of merchandise exports) of El Salvador in 2004 and the Imports(as % of merchandise exports) of Mongolia in 2007?
Make the answer very short. -15.82. What is the difference between the Imports(as % of merchandise exports) of El Salvador in 2004 and the Imports(as % of merchandise exports) of Senegal in 2007?
Offer a very short reply. -15.57. What is the difference between the Imports(as % of merchandise exports) of El Salvador in 2004 and the Imports(as % of merchandise exports) of Ukraine in 2007?
Your response must be concise. -15.25. What is the difference between the Imports(as % of merchandise exports) in Mongolia in 2004 and the Imports(as % of merchandise exports) in Senegal in 2007?
Keep it short and to the point. -4.32. What is the difference between the Imports(as % of merchandise exports) of Mongolia in 2004 and the Imports(as % of merchandise exports) of Ukraine in 2007?
Make the answer very short. -3.99. What is the difference between the Imports(as % of merchandise exports) of Senegal in 2004 and the Imports(as % of merchandise exports) of Ukraine in 2007?
Offer a very short reply. -8. What is the difference between the Imports(as % of merchandise exports) of El Salvador in 2005 and the Imports(as % of merchandise exports) of Mongolia in 2006?
Your response must be concise. -15. What is the difference between the Imports(as % of merchandise exports) of El Salvador in 2005 and the Imports(as % of merchandise exports) of Senegal in 2006?
Keep it short and to the point. -11.6. What is the difference between the Imports(as % of merchandise exports) in El Salvador in 2005 and the Imports(as % of merchandise exports) in Ukraine in 2006?
Ensure brevity in your answer.  -13.98. What is the difference between the Imports(as % of merchandise exports) of Mongolia in 2005 and the Imports(as % of merchandise exports) of Senegal in 2006?
Your response must be concise. 0.74. What is the difference between the Imports(as % of merchandise exports) of Mongolia in 2005 and the Imports(as % of merchandise exports) of Ukraine in 2006?
Your answer should be compact. -1.63. What is the difference between the Imports(as % of merchandise exports) in Senegal in 2005 and the Imports(as % of merchandise exports) in Ukraine in 2006?
Give a very brief answer. -5.36. What is the difference between the Imports(as % of merchandise exports) in El Salvador in 2005 and the Imports(as % of merchandise exports) in Mongolia in 2007?
Keep it short and to the point. -12.61. What is the difference between the Imports(as % of merchandise exports) in El Salvador in 2005 and the Imports(as % of merchandise exports) in Senegal in 2007?
Your answer should be compact. -12.36. What is the difference between the Imports(as % of merchandise exports) of El Salvador in 2005 and the Imports(as % of merchandise exports) of Ukraine in 2007?
Ensure brevity in your answer.  -12.04. What is the difference between the Imports(as % of merchandise exports) of Mongolia in 2005 and the Imports(as % of merchandise exports) of Senegal in 2007?
Your answer should be compact. -0.02. What is the difference between the Imports(as % of merchandise exports) of Mongolia in 2005 and the Imports(as % of merchandise exports) of Ukraine in 2007?
Ensure brevity in your answer.  0.31. What is the difference between the Imports(as % of merchandise exports) of Senegal in 2005 and the Imports(as % of merchandise exports) of Ukraine in 2007?
Offer a terse response. -3.42. What is the difference between the Imports(as % of merchandise exports) in El Salvador in 2006 and the Imports(as % of merchandise exports) in Mongolia in 2007?
Provide a short and direct response. -12.97. What is the difference between the Imports(as % of merchandise exports) of El Salvador in 2006 and the Imports(as % of merchandise exports) of Senegal in 2007?
Give a very brief answer. -12.73. What is the difference between the Imports(as % of merchandise exports) in El Salvador in 2006 and the Imports(as % of merchandise exports) in Ukraine in 2007?
Give a very brief answer. -12.4. What is the difference between the Imports(as % of merchandise exports) of Mongolia in 2006 and the Imports(as % of merchandise exports) of Senegal in 2007?
Make the answer very short. 2.64. What is the difference between the Imports(as % of merchandise exports) in Mongolia in 2006 and the Imports(as % of merchandise exports) in Ukraine in 2007?
Ensure brevity in your answer.  2.96. What is the difference between the Imports(as % of merchandise exports) of Senegal in 2006 and the Imports(as % of merchandise exports) of Ukraine in 2007?
Provide a succinct answer. -0.44. What is the average Imports(as % of merchandise exports) of El Salvador per year?
Your response must be concise. 12.49. What is the average Imports(as % of merchandise exports) in Mongolia per year?
Ensure brevity in your answer.  22.78. What is the average Imports(as % of merchandise exports) in Senegal per year?
Your answer should be very brief. 20.24. What is the average Imports(as % of merchandise exports) in Ukraine per year?
Ensure brevity in your answer.  34.84. In the year 1999, what is the difference between the Imports(as % of merchandise exports) in El Salvador and Imports(as % of merchandise exports) in Mongolia?
Offer a terse response. -4.48. In the year 1999, what is the difference between the Imports(as % of merchandise exports) of El Salvador and Imports(as % of merchandise exports) of Senegal?
Your answer should be compact. 1.34. In the year 1999, what is the difference between the Imports(as % of merchandise exports) in El Salvador and Imports(as % of merchandise exports) in Ukraine?
Provide a succinct answer. -32.59. In the year 1999, what is the difference between the Imports(as % of merchandise exports) of Mongolia and Imports(as % of merchandise exports) of Senegal?
Ensure brevity in your answer.  5.82. In the year 1999, what is the difference between the Imports(as % of merchandise exports) in Mongolia and Imports(as % of merchandise exports) in Ukraine?
Offer a very short reply. -28.11. In the year 1999, what is the difference between the Imports(as % of merchandise exports) in Senegal and Imports(as % of merchandise exports) in Ukraine?
Give a very brief answer. -33.94. In the year 2000, what is the difference between the Imports(as % of merchandise exports) of El Salvador and Imports(as % of merchandise exports) of Mongolia?
Your answer should be very brief. -7.04. In the year 2000, what is the difference between the Imports(as % of merchandise exports) in El Salvador and Imports(as % of merchandise exports) in Senegal?
Make the answer very short. -10.48. In the year 2000, what is the difference between the Imports(as % of merchandise exports) of El Salvador and Imports(as % of merchandise exports) of Ukraine?
Give a very brief answer. -30.97. In the year 2000, what is the difference between the Imports(as % of merchandise exports) in Mongolia and Imports(as % of merchandise exports) in Senegal?
Your answer should be compact. -3.44. In the year 2000, what is the difference between the Imports(as % of merchandise exports) of Mongolia and Imports(as % of merchandise exports) of Ukraine?
Offer a terse response. -23.93. In the year 2000, what is the difference between the Imports(as % of merchandise exports) in Senegal and Imports(as % of merchandise exports) in Ukraine?
Offer a very short reply. -20.49. In the year 2001, what is the difference between the Imports(as % of merchandise exports) in El Salvador and Imports(as % of merchandise exports) in Mongolia?
Keep it short and to the point. -12.09. In the year 2001, what is the difference between the Imports(as % of merchandise exports) of El Salvador and Imports(as % of merchandise exports) of Senegal?
Keep it short and to the point. -6.81. In the year 2001, what is the difference between the Imports(as % of merchandise exports) of El Salvador and Imports(as % of merchandise exports) of Ukraine?
Provide a succinct answer. -29.66. In the year 2001, what is the difference between the Imports(as % of merchandise exports) in Mongolia and Imports(as % of merchandise exports) in Senegal?
Your answer should be very brief. 5.29. In the year 2001, what is the difference between the Imports(as % of merchandise exports) in Mongolia and Imports(as % of merchandise exports) in Ukraine?
Provide a short and direct response. -17.57. In the year 2001, what is the difference between the Imports(as % of merchandise exports) of Senegal and Imports(as % of merchandise exports) of Ukraine?
Make the answer very short. -22.86. In the year 2003, what is the difference between the Imports(as % of merchandise exports) of El Salvador and Imports(as % of merchandise exports) of Mongolia?
Ensure brevity in your answer.  -9.06. In the year 2003, what is the difference between the Imports(as % of merchandise exports) in El Salvador and Imports(as % of merchandise exports) in Senegal?
Your answer should be very brief. -7.78. In the year 2003, what is the difference between the Imports(as % of merchandise exports) in El Salvador and Imports(as % of merchandise exports) in Ukraine?
Offer a very short reply. -23.3. In the year 2003, what is the difference between the Imports(as % of merchandise exports) in Mongolia and Imports(as % of merchandise exports) in Senegal?
Give a very brief answer. 1.28. In the year 2003, what is the difference between the Imports(as % of merchandise exports) of Mongolia and Imports(as % of merchandise exports) of Ukraine?
Give a very brief answer. -14.24. In the year 2003, what is the difference between the Imports(as % of merchandise exports) of Senegal and Imports(as % of merchandise exports) of Ukraine?
Your answer should be compact. -15.52. In the year 2004, what is the difference between the Imports(as % of merchandise exports) of El Salvador and Imports(as % of merchandise exports) of Mongolia?
Your answer should be very brief. -11.25. In the year 2004, what is the difference between the Imports(as % of merchandise exports) in El Salvador and Imports(as % of merchandise exports) in Senegal?
Offer a terse response. -7.25. In the year 2004, what is the difference between the Imports(as % of merchandise exports) of El Salvador and Imports(as % of merchandise exports) of Ukraine?
Offer a very short reply. -22.55. In the year 2004, what is the difference between the Imports(as % of merchandise exports) of Mongolia and Imports(as % of merchandise exports) of Senegal?
Ensure brevity in your answer.  4.01. In the year 2004, what is the difference between the Imports(as % of merchandise exports) of Mongolia and Imports(as % of merchandise exports) of Ukraine?
Offer a very short reply. -11.3. In the year 2004, what is the difference between the Imports(as % of merchandise exports) of Senegal and Imports(as % of merchandise exports) of Ukraine?
Give a very brief answer. -15.3. In the year 2005, what is the difference between the Imports(as % of merchandise exports) of El Salvador and Imports(as % of merchandise exports) of Mongolia?
Offer a very short reply. -12.34. In the year 2005, what is the difference between the Imports(as % of merchandise exports) of El Salvador and Imports(as % of merchandise exports) of Senegal?
Your response must be concise. -8.62. In the year 2005, what is the difference between the Imports(as % of merchandise exports) of El Salvador and Imports(as % of merchandise exports) of Ukraine?
Offer a terse response. -15.31. In the year 2005, what is the difference between the Imports(as % of merchandise exports) of Mongolia and Imports(as % of merchandise exports) of Senegal?
Your answer should be very brief. 3.73. In the year 2005, what is the difference between the Imports(as % of merchandise exports) in Mongolia and Imports(as % of merchandise exports) in Ukraine?
Keep it short and to the point. -2.97. In the year 2005, what is the difference between the Imports(as % of merchandise exports) in Senegal and Imports(as % of merchandise exports) in Ukraine?
Offer a very short reply. -6.7. In the year 2006, what is the difference between the Imports(as % of merchandise exports) in El Salvador and Imports(as % of merchandise exports) in Mongolia?
Offer a very short reply. -15.37. In the year 2006, what is the difference between the Imports(as % of merchandise exports) of El Salvador and Imports(as % of merchandise exports) of Senegal?
Make the answer very short. -11.97. In the year 2006, what is the difference between the Imports(as % of merchandise exports) of El Salvador and Imports(as % of merchandise exports) of Ukraine?
Your answer should be compact. -14.34. In the year 2006, what is the difference between the Imports(as % of merchandise exports) in Mongolia and Imports(as % of merchandise exports) in Senegal?
Give a very brief answer. 3.4. In the year 2006, what is the difference between the Imports(as % of merchandise exports) in Mongolia and Imports(as % of merchandise exports) in Ukraine?
Make the answer very short. 1.02. In the year 2006, what is the difference between the Imports(as % of merchandise exports) of Senegal and Imports(as % of merchandise exports) of Ukraine?
Your answer should be very brief. -2.37. In the year 2007, what is the difference between the Imports(as % of merchandise exports) in El Salvador and Imports(as % of merchandise exports) in Mongolia?
Your response must be concise. -10.63. In the year 2007, what is the difference between the Imports(as % of merchandise exports) in El Salvador and Imports(as % of merchandise exports) in Senegal?
Offer a very short reply. -10.38. In the year 2007, what is the difference between the Imports(as % of merchandise exports) in El Salvador and Imports(as % of merchandise exports) in Ukraine?
Provide a succinct answer. -10.06. In the year 2007, what is the difference between the Imports(as % of merchandise exports) in Mongolia and Imports(as % of merchandise exports) in Senegal?
Provide a short and direct response. 0.25. In the year 2007, what is the difference between the Imports(as % of merchandise exports) of Mongolia and Imports(as % of merchandise exports) of Ukraine?
Keep it short and to the point. 0.57. In the year 2007, what is the difference between the Imports(as % of merchandise exports) of Senegal and Imports(as % of merchandise exports) of Ukraine?
Ensure brevity in your answer.  0.32. What is the ratio of the Imports(as % of merchandise exports) of El Salvador in 1999 to that in 2000?
Your answer should be very brief. 0.95. What is the ratio of the Imports(as % of merchandise exports) in Mongolia in 1999 to that in 2000?
Give a very brief answer. 0.84. What is the ratio of the Imports(as % of merchandise exports) of Senegal in 1999 to that in 2000?
Give a very brief answer. 0.45. What is the ratio of the Imports(as % of merchandise exports) of El Salvador in 1999 to that in 2001?
Offer a very short reply. 1.15. What is the ratio of the Imports(as % of merchandise exports) in Mongolia in 1999 to that in 2001?
Make the answer very short. 0.72. What is the ratio of the Imports(as % of merchandise exports) in Senegal in 1999 to that in 2001?
Offer a very short reply. 0.6. What is the ratio of the Imports(as % of merchandise exports) of Ukraine in 1999 to that in 2001?
Ensure brevity in your answer.  1.11. What is the ratio of the Imports(as % of merchandise exports) in El Salvador in 1999 to that in 2003?
Provide a short and direct response. 1.06. What is the ratio of the Imports(as % of merchandise exports) in Mongolia in 1999 to that in 2003?
Keep it short and to the point. 0.8. What is the ratio of the Imports(as % of merchandise exports) of Senegal in 1999 to that in 2003?
Ensure brevity in your answer.  0.55. What is the ratio of the Imports(as % of merchandise exports) of Ukraine in 1999 to that in 2003?
Your answer should be very brief. 1.29. What is the ratio of the Imports(as % of merchandise exports) of El Salvador in 1999 to that in 2004?
Provide a short and direct response. 1.04. What is the ratio of the Imports(as % of merchandise exports) of Mongolia in 1999 to that in 2004?
Give a very brief answer. 0.72. What is the ratio of the Imports(as % of merchandise exports) of Senegal in 1999 to that in 2004?
Your response must be concise. 0.55. What is the ratio of the Imports(as % of merchandise exports) of Ukraine in 1999 to that in 2004?
Your response must be concise. 1.31. What is the ratio of the Imports(as % of merchandise exports) in El Salvador in 1999 to that in 2005?
Offer a very short reply. 0.8. What is the ratio of the Imports(as % of merchandise exports) of Mongolia in 1999 to that in 2005?
Make the answer very short. 0.6. What is the ratio of the Imports(as % of merchandise exports) in Senegal in 1999 to that in 2005?
Your response must be concise. 0.44. What is the ratio of the Imports(as % of merchandise exports) of Ukraine in 1999 to that in 2005?
Make the answer very short. 1.49. What is the ratio of the Imports(as % of merchandise exports) in El Salvador in 1999 to that in 2006?
Your answer should be very brief. 0.82. What is the ratio of the Imports(as % of merchandise exports) of Mongolia in 1999 to that in 2006?
Provide a short and direct response. 0.55. What is the ratio of the Imports(as % of merchandise exports) of Senegal in 1999 to that in 2006?
Provide a short and direct response. 0.39. What is the ratio of the Imports(as % of merchandise exports) in Ukraine in 1999 to that in 2006?
Make the answer very short. 1.56. What is the ratio of the Imports(as % of merchandise exports) of El Salvador in 1999 to that in 2007?
Offer a terse response. 0.71. What is the ratio of the Imports(as % of merchandise exports) of Mongolia in 1999 to that in 2007?
Offer a very short reply. 0.59. What is the ratio of the Imports(as % of merchandise exports) of Senegal in 1999 to that in 2007?
Your answer should be compact. 0.38. What is the ratio of the Imports(as % of merchandise exports) of Ukraine in 1999 to that in 2007?
Give a very brief answer. 1.67. What is the ratio of the Imports(as % of merchandise exports) of El Salvador in 2000 to that in 2001?
Provide a short and direct response. 1.2. What is the ratio of the Imports(as % of merchandise exports) in Mongolia in 2000 to that in 2001?
Offer a very short reply. 0.86. What is the ratio of the Imports(as % of merchandise exports) in Senegal in 2000 to that in 2001?
Your response must be concise. 1.34. What is the ratio of the Imports(as % of merchandise exports) of Ukraine in 2000 to that in 2001?
Offer a very short reply. 1.08. What is the ratio of the Imports(as % of merchandise exports) in El Salvador in 2000 to that in 2003?
Provide a succinct answer. 1.11. What is the ratio of the Imports(as % of merchandise exports) of Mongolia in 2000 to that in 2003?
Provide a short and direct response. 0.96. What is the ratio of the Imports(as % of merchandise exports) of Senegal in 2000 to that in 2003?
Offer a terse response. 1.21. What is the ratio of the Imports(as % of merchandise exports) in Ukraine in 2000 to that in 2003?
Offer a very short reply. 1.26. What is the ratio of the Imports(as % of merchandise exports) in El Salvador in 2000 to that in 2004?
Keep it short and to the point. 1.09. What is the ratio of the Imports(as % of merchandise exports) of Mongolia in 2000 to that in 2004?
Provide a short and direct response. 0.85. What is the ratio of the Imports(as % of merchandise exports) in Senegal in 2000 to that in 2004?
Your answer should be compact. 1.23. What is the ratio of the Imports(as % of merchandise exports) in Ukraine in 2000 to that in 2004?
Offer a very short reply. 1.28. What is the ratio of the Imports(as % of merchandise exports) of El Salvador in 2000 to that in 2005?
Your answer should be compact. 0.84. What is the ratio of the Imports(as % of merchandise exports) of Mongolia in 2000 to that in 2005?
Your answer should be very brief. 0.72. What is the ratio of the Imports(as % of merchandise exports) of Senegal in 2000 to that in 2005?
Give a very brief answer. 0.98. What is the ratio of the Imports(as % of merchandise exports) in Ukraine in 2000 to that in 2005?
Provide a short and direct response. 1.45. What is the ratio of the Imports(as % of merchandise exports) of El Salvador in 2000 to that in 2006?
Ensure brevity in your answer.  0.86. What is the ratio of the Imports(as % of merchandise exports) in Mongolia in 2000 to that in 2006?
Your answer should be compact. 0.65. What is the ratio of the Imports(as % of merchandise exports) in Senegal in 2000 to that in 2006?
Keep it short and to the point. 0.87. What is the ratio of the Imports(as % of merchandise exports) in Ukraine in 2000 to that in 2006?
Offer a very short reply. 1.52. What is the ratio of the Imports(as % of merchandise exports) in El Salvador in 2000 to that in 2007?
Provide a succinct answer. 0.74. What is the ratio of the Imports(as % of merchandise exports) in Mongolia in 2000 to that in 2007?
Make the answer very short. 0.71. What is the ratio of the Imports(as % of merchandise exports) in Senegal in 2000 to that in 2007?
Provide a short and direct response. 0.84. What is the ratio of the Imports(as % of merchandise exports) of Ukraine in 2000 to that in 2007?
Your answer should be compact. 1.63. What is the ratio of the Imports(as % of merchandise exports) in El Salvador in 2001 to that in 2003?
Your response must be concise. 0.92. What is the ratio of the Imports(as % of merchandise exports) of Mongolia in 2001 to that in 2003?
Provide a succinct answer. 1.11. What is the ratio of the Imports(as % of merchandise exports) of Senegal in 2001 to that in 2003?
Provide a short and direct response. 0.9. What is the ratio of the Imports(as % of merchandise exports) in Ukraine in 2001 to that in 2003?
Ensure brevity in your answer.  1.16. What is the ratio of the Imports(as % of merchandise exports) in El Salvador in 2001 to that in 2004?
Provide a succinct answer. 0.9. What is the ratio of the Imports(as % of merchandise exports) in Mongolia in 2001 to that in 2004?
Offer a very short reply. 0.99. What is the ratio of the Imports(as % of merchandise exports) in Ukraine in 2001 to that in 2004?
Ensure brevity in your answer.  1.18. What is the ratio of the Imports(as % of merchandise exports) in El Salvador in 2001 to that in 2005?
Your response must be concise. 0.7. What is the ratio of the Imports(as % of merchandise exports) in Mongolia in 2001 to that in 2005?
Give a very brief answer. 0.83. What is the ratio of the Imports(as % of merchandise exports) in Senegal in 2001 to that in 2005?
Keep it short and to the point. 0.73. What is the ratio of the Imports(as % of merchandise exports) of Ukraine in 2001 to that in 2005?
Make the answer very short. 1.34. What is the ratio of the Imports(as % of merchandise exports) in El Salvador in 2001 to that in 2006?
Ensure brevity in your answer.  0.72. What is the ratio of the Imports(as % of merchandise exports) in Mongolia in 2001 to that in 2006?
Offer a very short reply. 0.75. What is the ratio of the Imports(as % of merchandise exports) in Senegal in 2001 to that in 2006?
Your response must be concise. 0.65. What is the ratio of the Imports(as % of merchandise exports) of Ukraine in 2001 to that in 2006?
Your answer should be compact. 1.4. What is the ratio of the Imports(as % of merchandise exports) of El Salvador in 2001 to that in 2007?
Provide a short and direct response. 0.61. What is the ratio of the Imports(as % of merchandise exports) of Mongolia in 2001 to that in 2007?
Make the answer very short. 0.82. What is the ratio of the Imports(as % of merchandise exports) in Senegal in 2001 to that in 2007?
Give a very brief answer. 0.63. What is the ratio of the Imports(as % of merchandise exports) of Ukraine in 2001 to that in 2007?
Offer a terse response. 1.51. What is the ratio of the Imports(as % of merchandise exports) in El Salvador in 2003 to that in 2004?
Offer a terse response. 0.98. What is the ratio of the Imports(as % of merchandise exports) of Mongolia in 2003 to that in 2004?
Keep it short and to the point. 0.89. What is the ratio of the Imports(as % of merchandise exports) of Senegal in 2003 to that in 2004?
Provide a short and direct response. 1.02. What is the ratio of the Imports(as % of merchandise exports) in Ukraine in 2003 to that in 2004?
Offer a very short reply. 1.01. What is the ratio of the Imports(as % of merchandise exports) of El Salvador in 2003 to that in 2005?
Provide a short and direct response. 0.76. What is the ratio of the Imports(as % of merchandise exports) of Mongolia in 2003 to that in 2005?
Offer a very short reply. 0.75. What is the ratio of the Imports(as % of merchandise exports) in Senegal in 2003 to that in 2005?
Give a very brief answer. 0.81. What is the ratio of the Imports(as % of merchandise exports) in Ukraine in 2003 to that in 2005?
Your response must be concise. 1.15. What is the ratio of the Imports(as % of merchandise exports) in El Salvador in 2003 to that in 2006?
Your answer should be compact. 0.78. What is the ratio of the Imports(as % of merchandise exports) in Mongolia in 2003 to that in 2006?
Your answer should be compact. 0.68. What is the ratio of the Imports(as % of merchandise exports) in Senegal in 2003 to that in 2006?
Your response must be concise. 0.72. What is the ratio of the Imports(as % of merchandise exports) in Ukraine in 2003 to that in 2006?
Keep it short and to the point. 1.21. What is the ratio of the Imports(as % of merchandise exports) in El Salvador in 2003 to that in 2007?
Your answer should be compact. 0.67. What is the ratio of the Imports(as % of merchandise exports) in Mongolia in 2003 to that in 2007?
Make the answer very short. 0.74. What is the ratio of the Imports(as % of merchandise exports) in Senegal in 2003 to that in 2007?
Ensure brevity in your answer.  0.7. What is the ratio of the Imports(as % of merchandise exports) in Ukraine in 2003 to that in 2007?
Keep it short and to the point. 1.3. What is the ratio of the Imports(as % of merchandise exports) of El Salvador in 2004 to that in 2005?
Offer a very short reply. 0.78. What is the ratio of the Imports(as % of merchandise exports) in Mongolia in 2004 to that in 2005?
Your response must be concise. 0.84. What is the ratio of the Imports(as % of merchandise exports) in Senegal in 2004 to that in 2005?
Make the answer very short. 0.8. What is the ratio of the Imports(as % of merchandise exports) of Ukraine in 2004 to that in 2005?
Offer a terse response. 1.14. What is the ratio of the Imports(as % of merchandise exports) in El Salvador in 2004 to that in 2006?
Your answer should be compact. 0.8. What is the ratio of the Imports(as % of merchandise exports) of Mongolia in 2004 to that in 2006?
Offer a terse response. 0.76. What is the ratio of the Imports(as % of merchandise exports) of Senegal in 2004 to that in 2006?
Offer a terse response. 0.71. What is the ratio of the Imports(as % of merchandise exports) in Ukraine in 2004 to that in 2006?
Make the answer very short. 1.19. What is the ratio of the Imports(as % of merchandise exports) in El Salvador in 2004 to that in 2007?
Your answer should be very brief. 0.68. What is the ratio of the Imports(as % of merchandise exports) in Mongolia in 2004 to that in 2007?
Ensure brevity in your answer.  0.83. What is the ratio of the Imports(as % of merchandise exports) in Senegal in 2004 to that in 2007?
Your response must be concise. 0.69. What is the ratio of the Imports(as % of merchandise exports) of Ukraine in 2004 to that in 2007?
Offer a terse response. 1.28. What is the ratio of the Imports(as % of merchandise exports) of El Salvador in 2005 to that in 2006?
Provide a succinct answer. 1.03. What is the ratio of the Imports(as % of merchandise exports) in Mongolia in 2005 to that in 2006?
Your answer should be compact. 0.91. What is the ratio of the Imports(as % of merchandise exports) of Senegal in 2005 to that in 2006?
Make the answer very short. 0.88. What is the ratio of the Imports(as % of merchandise exports) in Ukraine in 2005 to that in 2006?
Keep it short and to the point. 1.05. What is the ratio of the Imports(as % of merchandise exports) of El Salvador in 2005 to that in 2007?
Your answer should be compact. 0.88. What is the ratio of the Imports(as % of merchandise exports) of Senegal in 2005 to that in 2007?
Offer a terse response. 0.86. What is the ratio of the Imports(as % of merchandise exports) of Ukraine in 2005 to that in 2007?
Offer a terse response. 1.12. What is the ratio of the Imports(as % of merchandise exports) in El Salvador in 2006 to that in 2007?
Offer a terse response. 0.86. What is the ratio of the Imports(as % of merchandise exports) of Mongolia in 2006 to that in 2007?
Your response must be concise. 1.09. What is the ratio of the Imports(as % of merchandise exports) in Senegal in 2006 to that in 2007?
Your answer should be very brief. 0.97. What is the ratio of the Imports(as % of merchandise exports) in Ukraine in 2006 to that in 2007?
Make the answer very short. 1.07. What is the difference between the highest and the second highest Imports(as % of merchandise exports) of El Salvador?
Keep it short and to the point. 1.98. What is the difference between the highest and the second highest Imports(as % of merchandise exports) in Mongolia?
Give a very brief answer. 2.39. What is the difference between the highest and the second highest Imports(as % of merchandise exports) of Senegal?
Your answer should be very brief. 0.76. What is the difference between the highest and the second highest Imports(as % of merchandise exports) of Ukraine?
Your answer should be compact. 1.08. What is the difference between the highest and the lowest Imports(as % of merchandise exports) in El Salvador?
Keep it short and to the point. 6.27. What is the difference between the highest and the lowest Imports(as % of merchandise exports) of Mongolia?
Provide a short and direct response. 13.32. What is the difference between the highest and the lowest Imports(as % of merchandise exports) in Senegal?
Ensure brevity in your answer.  16.5. What is the difference between the highest and the lowest Imports(as % of merchandise exports) in Ukraine?
Provide a succinct answer. 17.75. 